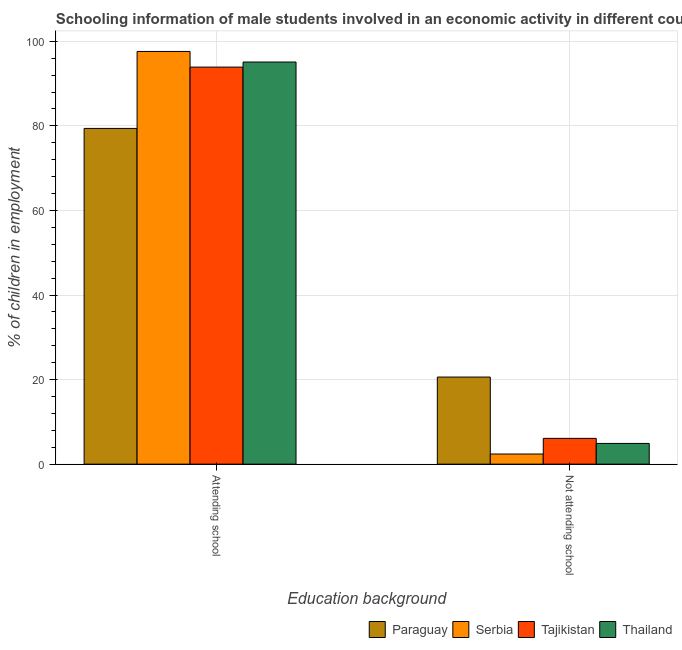How many different coloured bars are there?
Give a very brief answer. 4. How many groups of bars are there?
Make the answer very short. 2. Are the number of bars per tick equal to the number of legend labels?
Ensure brevity in your answer.  Yes. Are the number of bars on each tick of the X-axis equal?
Give a very brief answer. Yes. How many bars are there on the 1st tick from the left?
Provide a short and direct response. 4. What is the label of the 2nd group of bars from the left?
Offer a very short reply. Not attending school. What is the percentage of employed males who are attending school in Paraguay?
Give a very brief answer. 79.4. Across all countries, what is the maximum percentage of employed males who are attending school?
Ensure brevity in your answer.  97.6. In which country was the percentage of employed males who are not attending school maximum?
Your answer should be very brief. Paraguay. In which country was the percentage of employed males who are not attending school minimum?
Your answer should be compact. Serbia. What is the total percentage of employed males who are not attending school in the graph?
Provide a succinct answer. 34. What is the difference between the percentage of employed males who are attending school in Thailand and that in Tajikistan?
Your answer should be compact. 1.2. What is the difference between the percentage of employed males who are not attending school in Serbia and the percentage of employed males who are attending school in Tajikistan?
Your response must be concise. -91.5. What is the difference between the percentage of employed males who are attending school and percentage of employed males who are not attending school in Tajikistan?
Provide a short and direct response. 87.8. What is the ratio of the percentage of employed males who are not attending school in Tajikistan to that in Paraguay?
Your response must be concise. 0.3. In how many countries, is the percentage of employed males who are not attending school greater than the average percentage of employed males who are not attending school taken over all countries?
Your answer should be compact. 1. What does the 2nd bar from the left in Attending school represents?
Your answer should be compact. Serbia. What does the 2nd bar from the right in Not attending school represents?
Provide a succinct answer. Tajikistan. How many bars are there?
Ensure brevity in your answer.  8. How many countries are there in the graph?
Keep it short and to the point. 4. What is the difference between two consecutive major ticks on the Y-axis?
Offer a terse response. 20. Does the graph contain grids?
Keep it short and to the point. Yes. How are the legend labels stacked?
Your answer should be compact. Horizontal. What is the title of the graph?
Provide a succinct answer. Schooling information of male students involved in an economic activity in different countries. What is the label or title of the X-axis?
Offer a terse response. Education background. What is the label or title of the Y-axis?
Your response must be concise. % of children in employment. What is the % of children in employment in Paraguay in Attending school?
Your answer should be very brief. 79.4. What is the % of children in employment in Serbia in Attending school?
Offer a terse response. 97.6. What is the % of children in employment in Tajikistan in Attending school?
Keep it short and to the point. 93.9. What is the % of children in employment in Thailand in Attending school?
Keep it short and to the point. 95.1. What is the % of children in employment in Paraguay in Not attending school?
Make the answer very short. 20.6. What is the % of children in employment of Tajikistan in Not attending school?
Your response must be concise. 6.1. What is the % of children in employment in Thailand in Not attending school?
Keep it short and to the point. 4.9. Across all Education background, what is the maximum % of children in employment in Paraguay?
Provide a succinct answer. 79.4. Across all Education background, what is the maximum % of children in employment in Serbia?
Make the answer very short. 97.6. Across all Education background, what is the maximum % of children in employment in Tajikistan?
Keep it short and to the point. 93.9. Across all Education background, what is the maximum % of children in employment in Thailand?
Make the answer very short. 95.1. Across all Education background, what is the minimum % of children in employment of Paraguay?
Give a very brief answer. 20.6. Across all Education background, what is the minimum % of children in employment of Serbia?
Keep it short and to the point. 2.4. What is the total % of children in employment in Paraguay in the graph?
Make the answer very short. 100. What is the total % of children in employment of Thailand in the graph?
Your answer should be compact. 100. What is the difference between the % of children in employment of Paraguay in Attending school and that in Not attending school?
Provide a succinct answer. 58.8. What is the difference between the % of children in employment in Serbia in Attending school and that in Not attending school?
Provide a succinct answer. 95.2. What is the difference between the % of children in employment in Tajikistan in Attending school and that in Not attending school?
Make the answer very short. 87.8. What is the difference between the % of children in employment in Thailand in Attending school and that in Not attending school?
Offer a very short reply. 90.2. What is the difference between the % of children in employment in Paraguay in Attending school and the % of children in employment in Tajikistan in Not attending school?
Provide a succinct answer. 73.3. What is the difference between the % of children in employment of Paraguay in Attending school and the % of children in employment of Thailand in Not attending school?
Your answer should be very brief. 74.5. What is the difference between the % of children in employment of Serbia in Attending school and the % of children in employment of Tajikistan in Not attending school?
Keep it short and to the point. 91.5. What is the difference between the % of children in employment of Serbia in Attending school and the % of children in employment of Thailand in Not attending school?
Offer a terse response. 92.7. What is the difference between the % of children in employment of Tajikistan in Attending school and the % of children in employment of Thailand in Not attending school?
Your response must be concise. 89. What is the average % of children in employment in Paraguay per Education background?
Provide a succinct answer. 50. What is the average % of children in employment of Serbia per Education background?
Ensure brevity in your answer.  50. What is the average % of children in employment of Tajikistan per Education background?
Offer a very short reply. 50. What is the average % of children in employment in Thailand per Education background?
Ensure brevity in your answer.  50. What is the difference between the % of children in employment in Paraguay and % of children in employment in Serbia in Attending school?
Keep it short and to the point. -18.2. What is the difference between the % of children in employment in Paraguay and % of children in employment in Thailand in Attending school?
Ensure brevity in your answer.  -15.7. What is the difference between the % of children in employment of Paraguay and % of children in employment of Serbia in Not attending school?
Ensure brevity in your answer.  18.2. What is the difference between the % of children in employment of Paraguay and % of children in employment of Tajikistan in Not attending school?
Make the answer very short. 14.5. What is the difference between the % of children in employment of Paraguay and % of children in employment of Thailand in Not attending school?
Provide a succinct answer. 15.7. What is the difference between the % of children in employment of Serbia and % of children in employment of Tajikistan in Not attending school?
Your answer should be compact. -3.7. What is the ratio of the % of children in employment of Paraguay in Attending school to that in Not attending school?
Keep it short and to the point. 3.85. What is the ratio of the % of children in employment in Serbia in Attending school to that in Not attending school?
Give a very brief answer. 40.67. What is the ratio of the % of children in employment in Tajikistan in Attending school to that in Not attending school?
Ensure brevity in your answer.  15.39. What is the ratio of the % of children in employment of Thailand in Attending school to that in Not attending school?
Ensure brevity in your answer.  19.41. What is the difference between the highest and the second highest % of children in employment in Paraguay?
Your response must be concise. 58.8. What is the difference between the highest and the second highest % of children in employment in Serbia?
Keep it short and to the point. 95.2. What is the difference between the highest and the second highest % of children in employment in Tajikistan?
Give a very brief answer. 87.8. What is the difference between the highest and the second highest % of children in employment in Thailand?
Your response must be concise. 90.2. What is the difference between the highest and the lowest % of children in employment in Paraguay?
Your response must be concise. 58.8. What is the difference between the highest and the lowest % of children in employment in Serbia?
Ensure brevity in your answer.  95.2. What is the difference between the highest and the lowest % of children in employment of Tajikistan?
Offer a terse response. 87.8. What is the difference between the highest and the lowest % of children in employment in Thailand?
Ensure brevity in your answer.  90.2. 